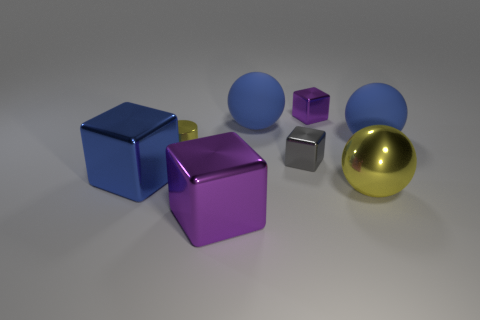Add 1 purple metallic blocks. How many objects exist? 9 Subtract all balls. How many objects are left? 5 Add 6 cubes. How many cubes exist? 10 Subtract 0 gray cylinders. How many objects are left? 8 Subtract all large yellow cylinders. Subtract all big shiny things. How many objects are left? 5 Add 6 large blue matte objects. How many large blue matte objects are left? 8 